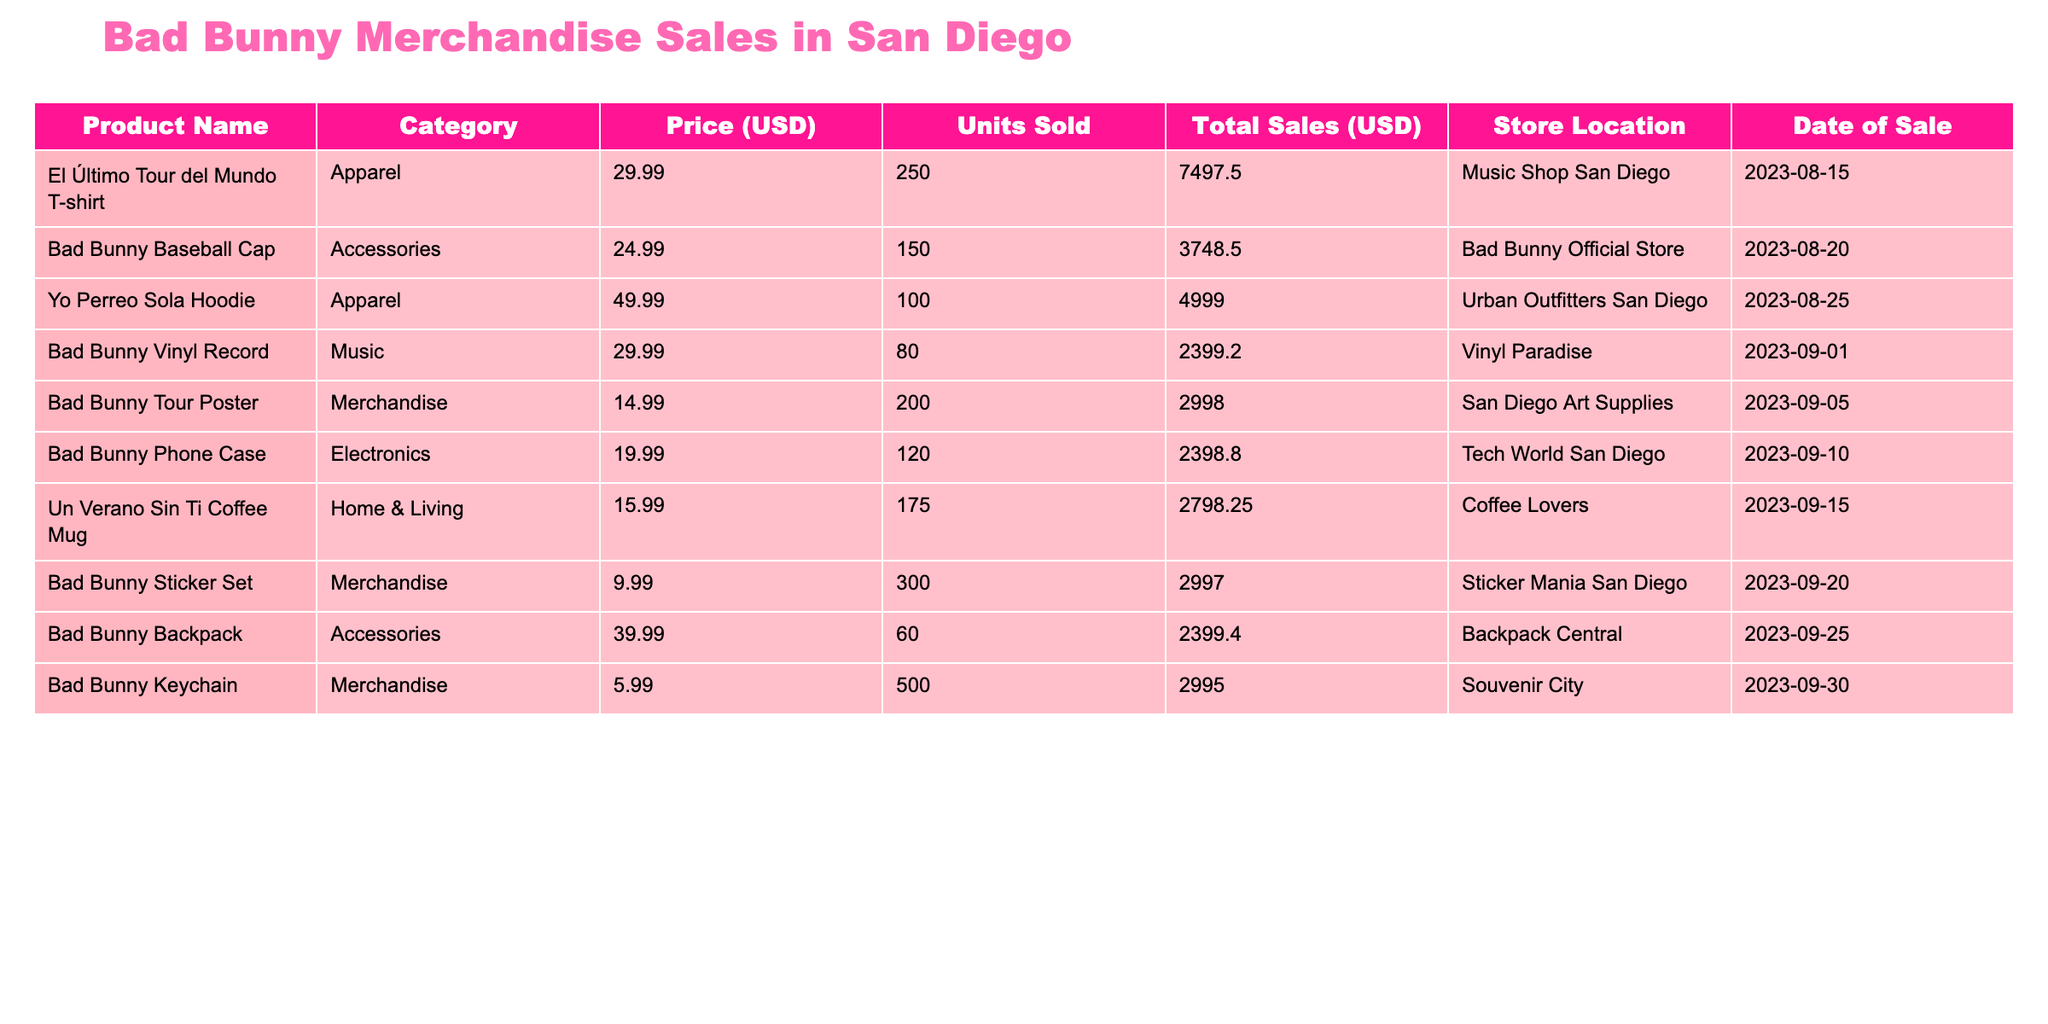What is the total sales generated by the "El Último Tour del Mundo T-shirt"? The total sales for this product can be found in the "Total Sales (USD)" column. It shows $7497.50 for this product.
Answer: $7497.50 How many units of the "Bad Bunny Keychain" were sold? Looking at the "Units Sold" column for "Bad Bunny Keychain," it indicates that 500 units were sold.
Answer: 500 What was the price of the "Yo Perreo Sola Hoodie"? The price can be found in the "Price (USD)" column corresponding to the "Yo Perreo Sola Hoodie," which is $49.99.
Answer: $49.99 Which product had the highest total sales? To find this, we compare the "Total Sales (USD)" for each product. The "El Último Tour del Mundo T-shirt" has the highest total sales of $7497.50.
Answer: "El Último Tour del Mundo T-shirt" What is the average price of the merchandise sold? First, sum the prices of all products: (29.99 + 24.99 + 49.99 + 29.99 + 14.99 + 19.99 + 15.99 + 9.99 + 39.99 + 5.99) = 240.90. Then, divide by the number of products (10). The average price is 240.90 / 10 = 24.09.
Answer: $24.09 True or False: More hoodies were sold than baseball caps. The "Yo Perreo Sola Hoodie" sold 100 units, while the "Bad Bunny Baseball Cap" had 150 units sold. Therefore, the statement is false.
Answer: False What is the total sales of all products classified under Merchandise? The total sales from merchandise products includes: $2998.00 (Bad Bunny Tour Poster) + $2997.00 (Bad Bunny Sticker Set) + $2995.00 (Bad Bunny Keychain) = $8990.00.
Answer: $8990.00 Which store location sold the "Bad Bunny Vinyl Record"? From the data, the "Bad Bunny Vinyl Record" is listed under "Vinyl Paradise."
Answer: Vinyl Paradise What was the total number of units sold across all categories? To find this total, add together all the units sold: (250 + 150 + 100 + 80 + 200 + 120 + 175 + 300 + 60 + 500) = 1935.
Answer: 1935 Which accessory had higher total sales, the "Bad Bunny Baseball Cap" or the "Bad Bunny Backpack"? The "Bad Bunny Baseball Cap" has total sales of $3748.50, while the "Bad Bunny Backpack" has total sales of $2399.40. Since $3748.50 > $2399.40, the cap had higher total sales.
Answer: Bad Bunny Baseball Cap How many more units of the "Bad Bunny Sticker Set" were sold compared to the "Un Verano Sin Ti Coffee Mug"? The "Bad Bunny Sticker Set" sold 300 units while the "Coffee Mug" sold 175 units. The difference is calculated as 300 - 175 = 125.
Answer: 125 